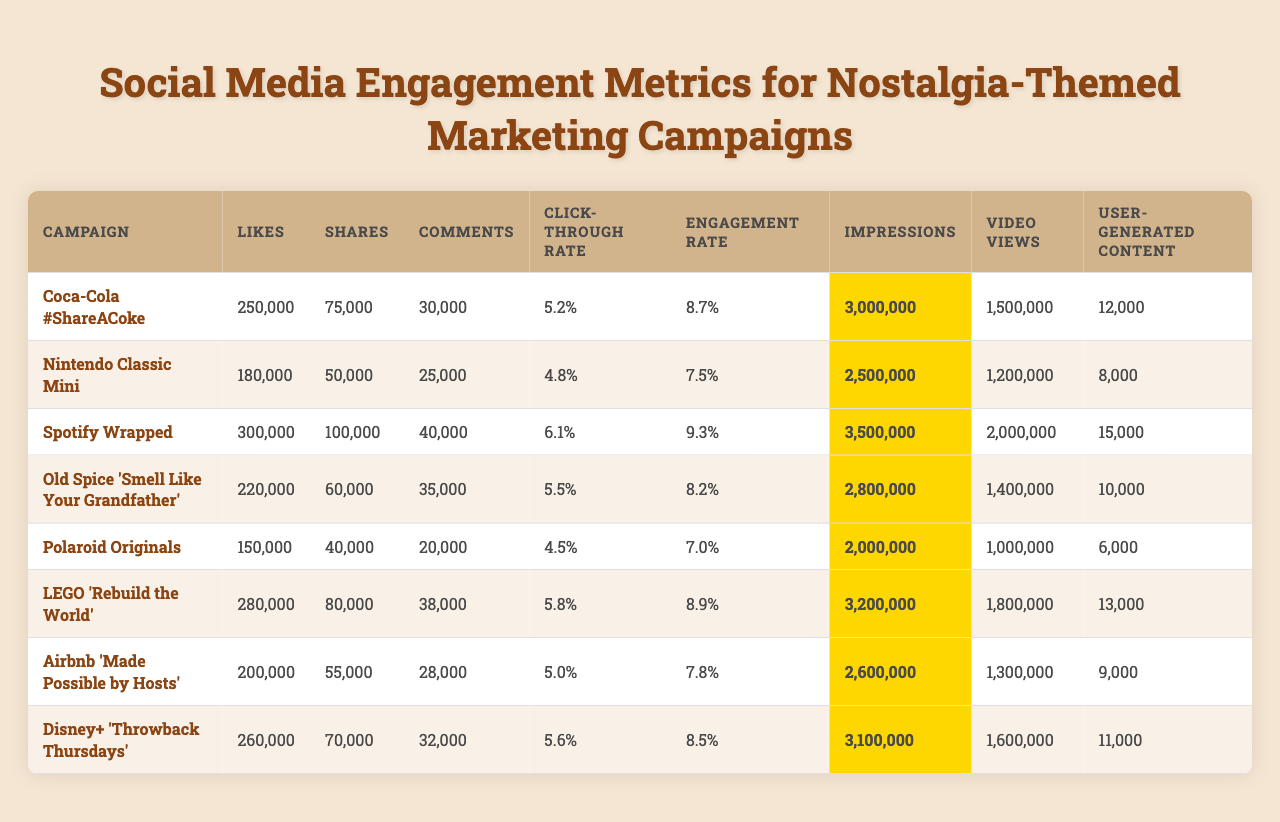What was the campaign with the highest number of Likes? The "Spotify Wrapped" campaign had the highest number of Likes at 300,000. This is determined by comparing the Likes across all campaigns in the table.
Answer: Spotify Wrapped Which campaign had the lowest engagement rate? The "Polaroid Originals" campaign had the lowest engagement rate of 7.0%, as observed directly from the table.
Answer: Polaroid Originals What is the average number of Shares for all campaigns? The total number of Shares is 75,000 + 50,000 + 100,000 + 60,000 + 40,000 + 80,000 + 55,000 + 70,000 = 520,000. There are 8 campaigns, so the average number of Shares is 520,000 / 8 = 65,000.
Answer: 65,000 Did the "Coca-Cola #ShareACoke" campaign have a higher Click-through rate than the "Old Spice 'Smell Like Your Grandfather'" campaign? The Click-through rate for "Coca-Cola #ShareACoke" is 5.2%, while for "Old Spice" it is 5.5%. Since 5.2% is less than 5.5%, the answer is no.
Answer: No What is the difference in Impressions between the "Nintendo Classic Mini" and the "LEGO 'Rebuild the World'" campaigns? The Impressions for "Nintendo Classic Mini" are 2,500,000 and for "LEGO 'Rebuild the World'" they are 3,200,000. The difference is 3,200,000 - 2,500,000 = 700,000.
Answer: 700,000 Which campaign generated the most User-generated content? "Spotify Wrapped" produced the most User-generated content with a total of 15,000. This is identified by comparing the User-generated content numbers across all campaigns in the table.
Answer: Spotify Wrapped What is the median number of Comments across the campaigns? The Comments in ascending order are 20,000, 25,000, 28,000, 30,000, 32,000, 35,000, 38,000, and 40,000. The median is the average of the 4th and 5th values, which are 30,000 and 32,000. The median is (30,000 + 32,000) / 2 = 31,000.
Answer: 31,000 Which campaign had the highest Click-through rate, and what is the value? The "Spotify Wrapped" campaign had the highest Click-through rate at 6.1%, as can be seen by comparing the Click-through rates for all campaigns in the table.
Answer: 6.1% Is the total number of Video views across all campaigns greater than 10 million? The total Video views are 1,500,000 + 1,200,000 + 2,000,000 + 1,400,000 + 1,000,000 + 1,800,000 + 1,300,000 + 1,600,000 = 12,500,000. Since 12,500,000 is greater than 10 million, the answer is yes.
Answer: Yes What percentage of Likes does the "Disney+ 'Throwback Thursdays'" campaign have compared to the total Likes of all campaigns? The total Likes are 250,000 + 180,000 + 300,000 + 220,000 + 150,000 + 280,000 + 200,000 + 260,000 = 1,840,000. The "Disney+ 'Throwback Thursdays'" campaign had 260,000 Likes, which is (260,000 / 1,840,000) * 100 = 14.13%.
Answer: 14.13% 